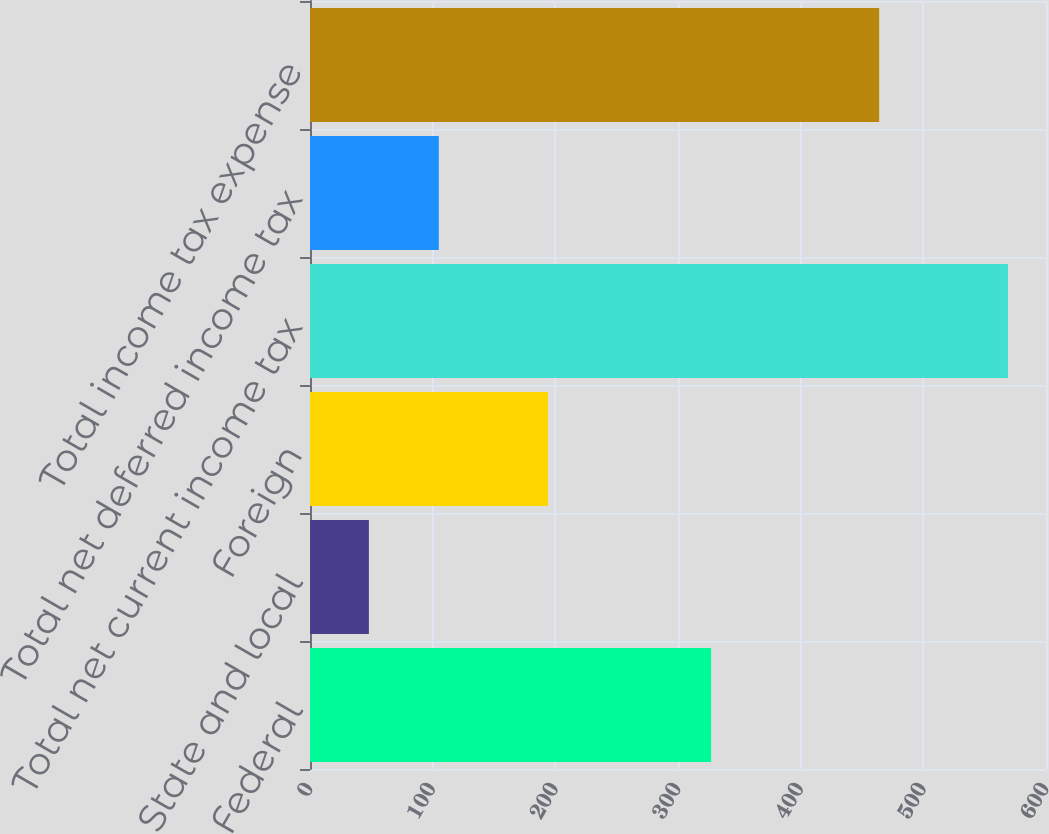<chart> <loc_0><loc_0><loc_500><loc_500><bar_chart><fcel>Federal<fcel>State and local<fcel>Foreign<fcel>Total net current income tax<fcel>Total net deferred income tax<fcel>Total income tax expense<nl><fcel>327<fcel>48<fcel>194<fcel>569<fcel>105<fcel>464<nl></chart> 